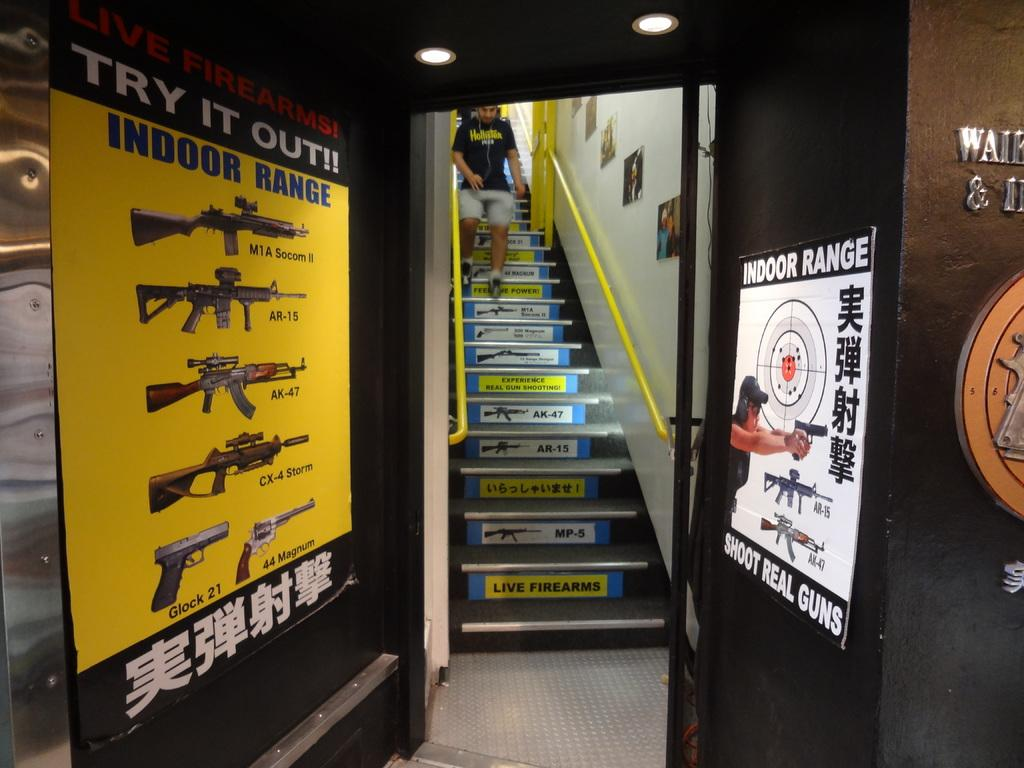<image>
Provide a brief description of the given image. An indoor range says to try it out has has pictures of guns. 